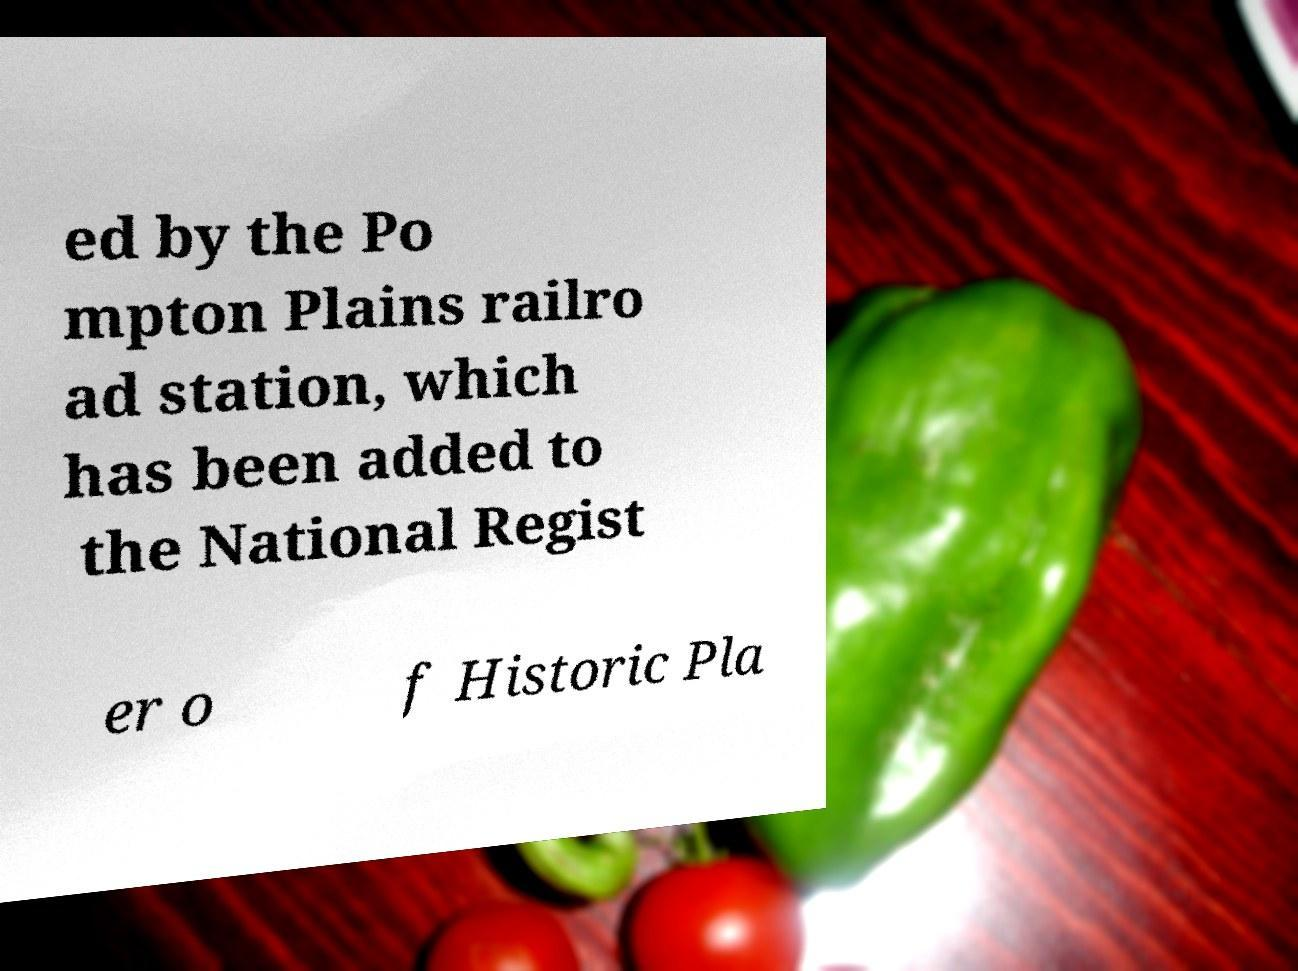Please read and relay the text visible in this image. What does it say? ed by the Po mpton Plains railro ad station, which has been added to the National Regist er o f Historic Pla 